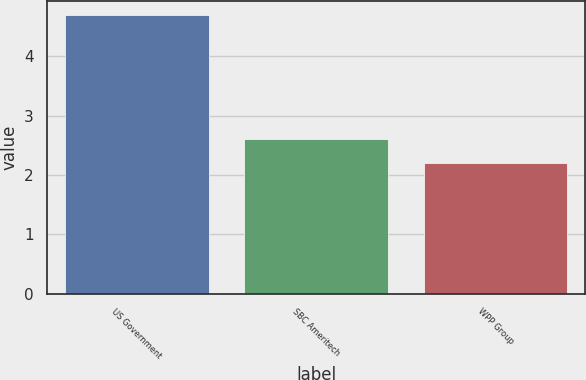Convert chart. <chart><loc_0><loc_0><loc_500><loc_500><bar_chart><fcel>US Government<fcel>SBC Ameritech<fcel>WPP Group<nl><fcel>4.7<fcel>2.6<fcel>2.2<nl></chart> 